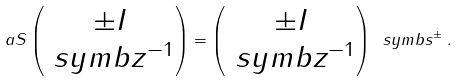<formula> <loc_0><loc_0><loc_500><loc_500>\ a S \begin{pmatrix} \pm I \\ \ s y m b { z } ^ { - 1 } \end{pmatrix} = \begin{pmatrix} \pm I \\ \ s y m b { z } ^ { - 1 } \end{pmatrix} \ s y m b { s } ^ { \pm } \, .</formula> 